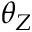<formula> <loc_0><loc_0><loc_500><loc_500>\theta _ { Z }</formula> 